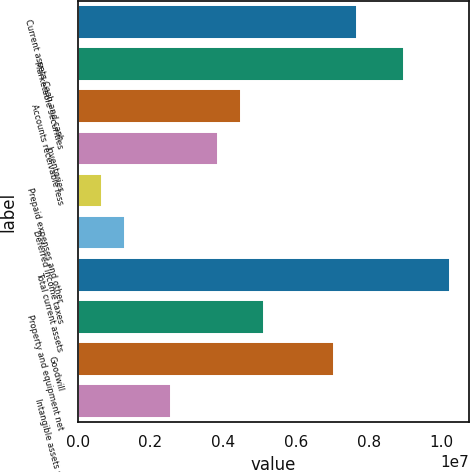Convert chart. <chart><loc_0><loc_0><loc_500><loc_500><bar_chart><fcel>Current assets Cash and cash<fcel>Marketable securities<fcel>Accounts receivable less<fcel>Inventories<fcel>Prepaid expenses and other<fcel>Deferred income taxes<fcel>Total current assets<fcel>Property and equipment net<fcel>Goodwill<fcel>Intangible assets net<nl><fcel>7.69089e+06<fcel>8.96954e+06<fcel>4.49427e+06<fcel>3.85495e+06<fcel>658323<fcel>1.29765e+06<fcel>1.02482e+07<fcel>5.1336e+06<fcel>7.05157e+06<fcel>2.5763e+06<nl></chart> 